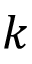<formula> <loc_0><loc_0><loc_500><loc_500>k</formula> 